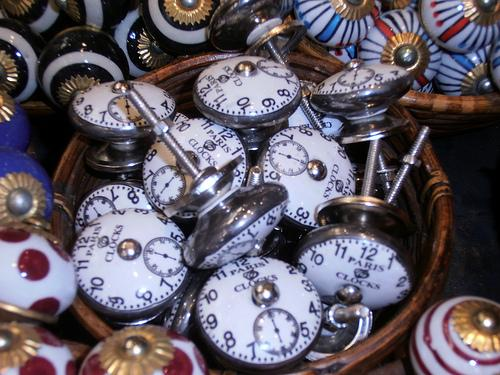Can you provide a brief description of what is inside the brown wicker basket? The brown wicker basket is holding a variety of decorative drawer knobs, featuring clock faces, colorful patterns, and metal accents. List three colors present in some of the objects in the image. Blue, red, and gold are present in some of the objects. Provide a general sentiment and atmosphere conveyed by the image. The image conveys a creative and cozy atmosphere, showcasing a variety of unique and decorative drawer knobs. Mention one of the designs found on the drawer knobs and at least one color in it. One of the drawer knob designs features red and white polka dots. Find two items in the image with a red design and describe their characteristics briefly. One item is a drawer knob with red stripes on a white background, and another item is a drawer knob featuring red sparkling polka dots. What type of object is located at the middle of the clock with a white and red design? A metal ball is located at the center of the clock with a white and red design. How many objects in the image have a clock design on them? There are at least eight objects in the image with a clock design. What is the main object displayed with various designs in this image? Drawer knobs with different designs such as clocks, polka dots, and stripes are the main objects displayed. Identify the material of the container holding the clock-themed items. The container holding the clock-themed items is made of brown wicker. What is the common element shared by some objects, like the small black number 10 and the screw on the back of the drawer knob? Both objects are related to decorative drawer knobs, either as a design detail or a functional part. Can you find the small green clock with a floral design in the bottom right corner?  There is no mention of a green clock with a floral design. This instruction is misleading because it asks to look for an object with an incorrect attribute and wrong position. Find the three different colors of the balls in the image. blue, black and white, and red and white Identify the color of the ball by the black and white items. black and white Describe the location of the gold ornamental topper in relation to the blue drawer knob. Is it (a) near bottom left (b) near top left (c) near bottom right? (b) near top left What is the main material of the bowl holding the clock items? wicker Which object features both gold accents and blue color?  blue drawer knob Where does the brown bunny with blue and white stripes sit? No brown bunny or any animal objects are mentioned in the image. This instruction is misleading because it asks to look for an object that doesn't exist. Where is the large purple ball located at the top of the image? There is no mention of a purple ball in any size or its position being at the top of the image. This instruction is misleading because it asks to look for an object that doesn't exist with an incorrect attribute and position. Can you point out the transparent glass clock at the center of the batch? No clock that exists in the image is mentioned to be transparent or made of glass. This instruction is misleading because it asks about an object with an incorrect attribute. Describe the red and white pok a dots object. clock drawer knob with red polka dot design Can you see a drawer knob with a zebra pattern near the middle of the image? There is no mention of any drawer knob with a zebra pattern. This instruction is misleading because it asks to look for a drawer knob with an incorrect attribute. What is the dominant color on the ball at the top left corner of the image?  blue Deduce the content of the text on the white clock face. Paris Clocks logo and company name Which object in the image contains several captions? small clock decor Create a sentence that describes the overall aesthetic appeal of the items in the image. The diverse colors and creative designs of the drawer knobs create a visually appealing composition. Write a creative and succinct caption for the image that includes the phrase "timepieces in disguise". Intricate timepieces in disguise: a variety of drawer knobs adorned with clock designs. Find the text or logo that mentions a city. Paris Clocks logo What unique feature can be found on some of the drawer knobs? clock design Why might someone be interested in purchasing the items displayed in the image? To use as unique and decorative drawer knobs in their home or furniture. Which of these items are held in the brown wicker basket? (a) clock screws (b) drawer knobs displayed (c) metal bolts and screws (b) drawer knobs displayed What time do the clock hands on the silver clock appear to show? Six o'clock What is the small black object on a white background? number 10 Can you find a clock with a Paris logo but colored yellow and green in the top left corner of the image? Although there is a mention of a Paris logo ("the words paris clocks and a logo"), the colors of the logo are not specified, and the location is not indicated as being in the top left corner. This instruction is misleading because it asks to look for an object with incorrect attributes and positions. What do the red stripes surround in the image? a white ball Choose the correct description of black drawer knob's design. (a) red polka dots (b) white stripe and gold accents (c) blue flowers (b) white stripe and gold accents 